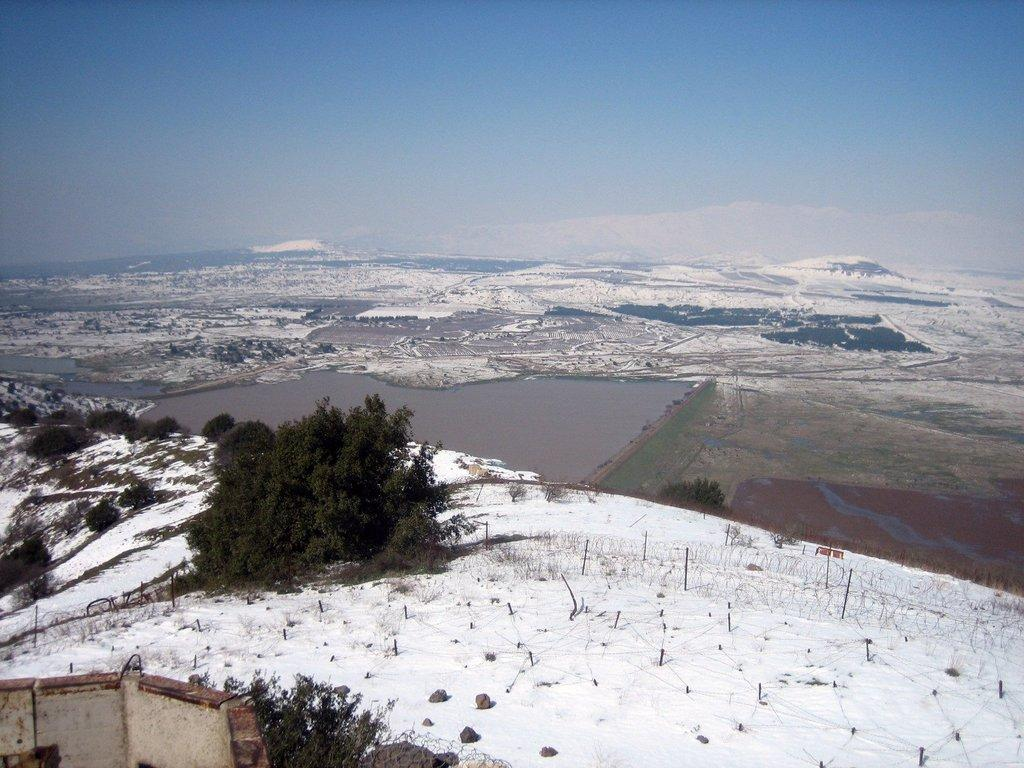What type of vegetation can be seen in the image? There are trees and plants visible in the image. What is the weather like in the image? The presence of snow suggests that it is cold or wintry in the image. What can be seen in the water in the image? The facts do not specify what is in the water, so we cannot answer that question definitively. What type of ground surface is present in the image? There are stones visible in the image, which suggests a rocky or stony ground surface. What is visible in the background of the image? The sky is visible in the background of the image. How many rabbits are sitting on the jar in the image? There is no jar or rabbits present in the image. What type of pest is causing damage to the plants in the image? There is no indication of any pests damaging the plants in the image. 